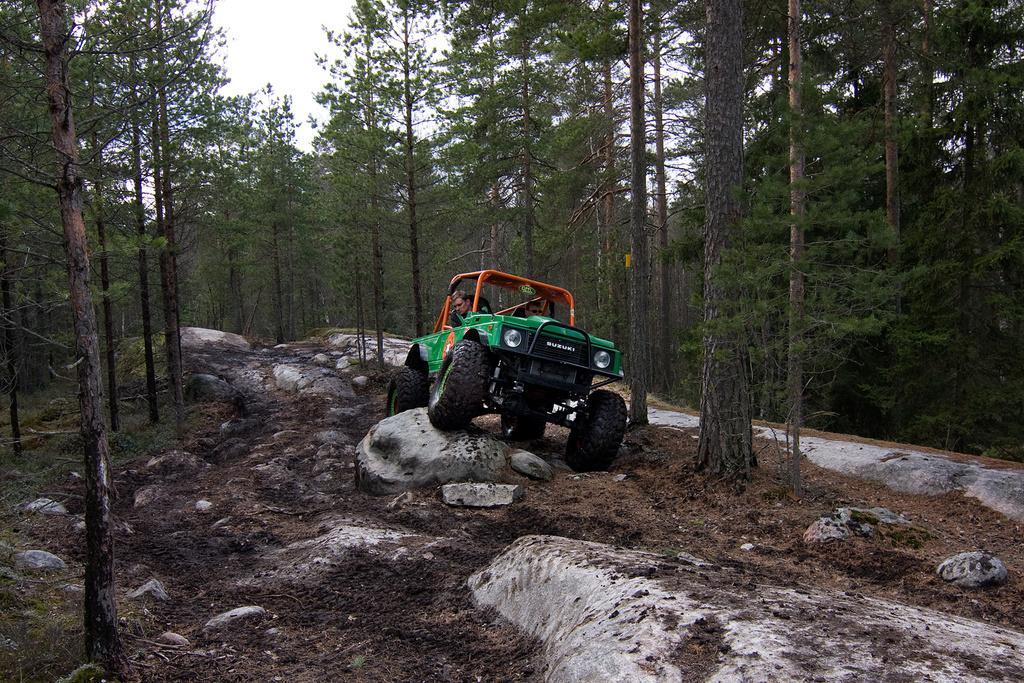How would you summarize this image in a sentence or two? In this picture we can see two people on a vehicle. There are few rocks and some trees in the background. 